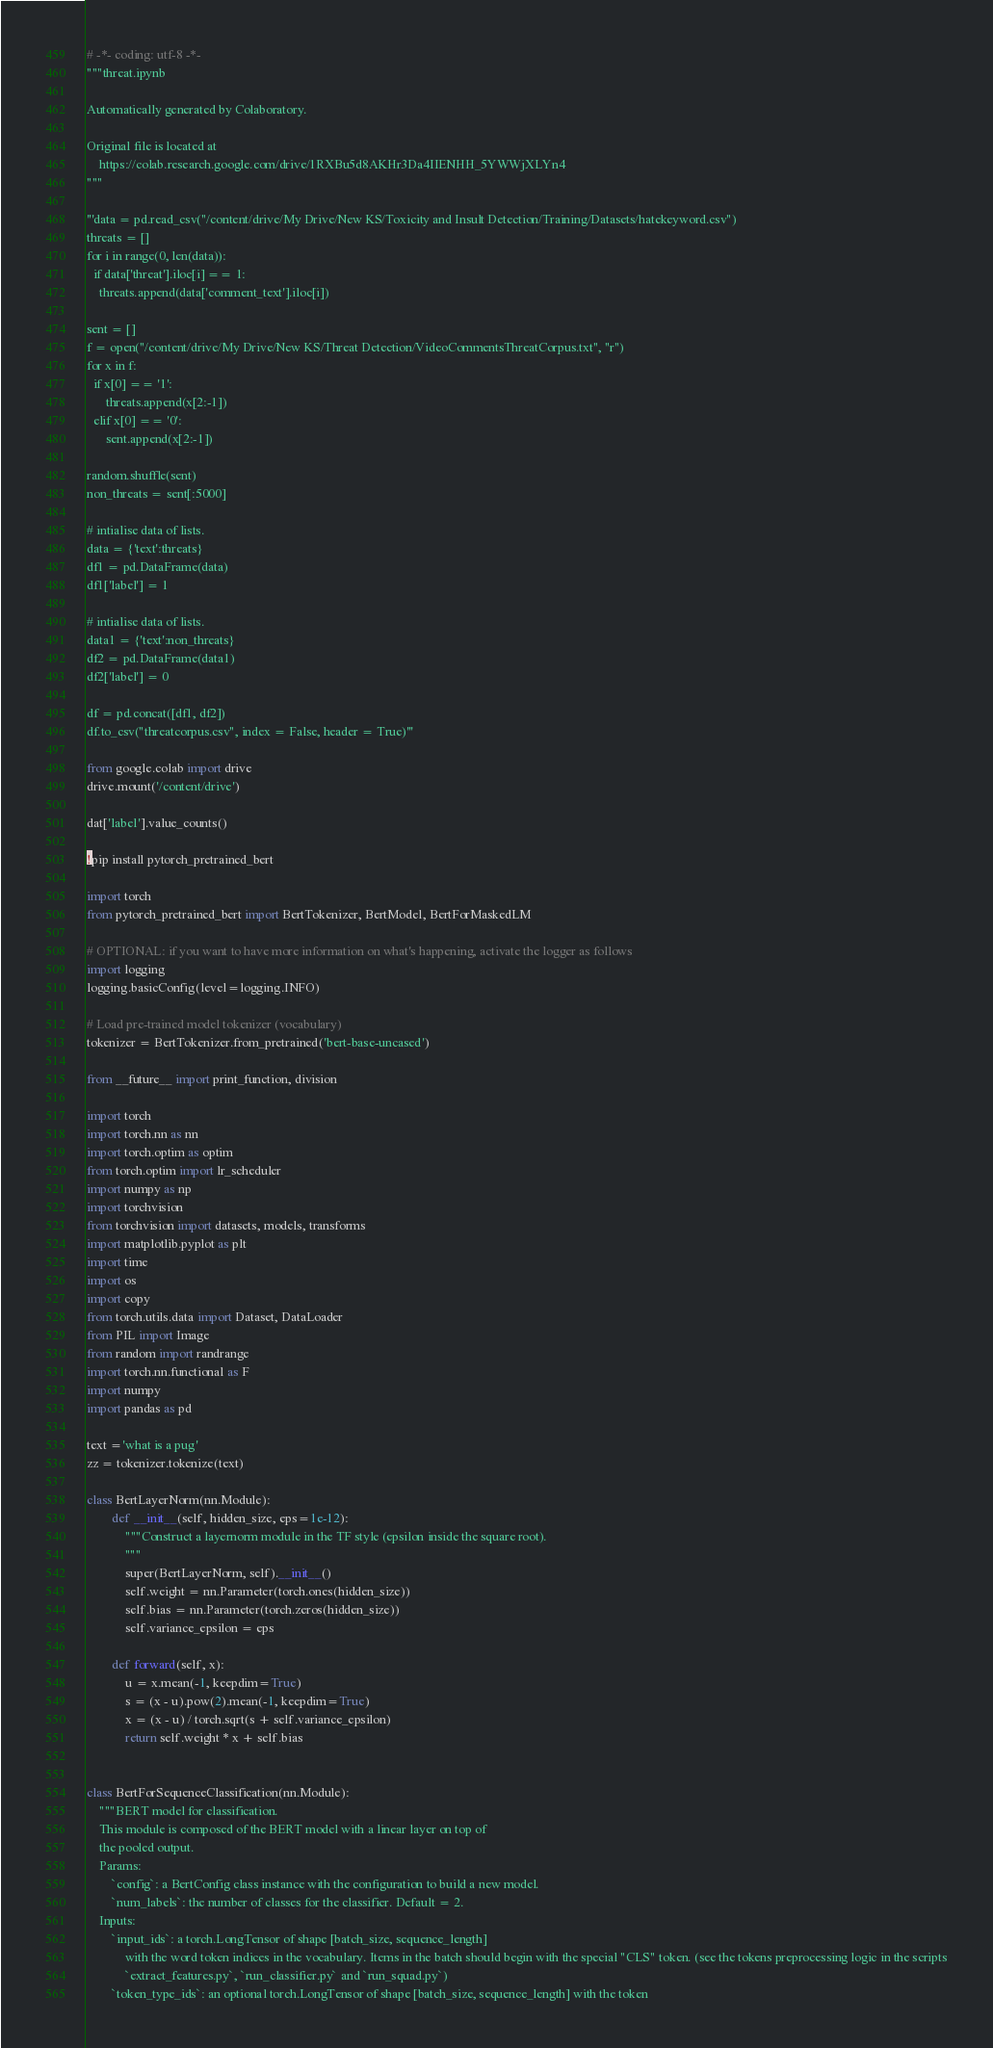Convert code to text. <code><loc_0><loc_0><loc_500><loc_500><_Python_># -*- coding: utf-8 -*-
"""threat.ipynb

Automatically generated by Colaboratory.

Original file is located at
    https://colab.research.google.com/drive/1RXBu5d8AKHr3Da4IIENHH_5YWWjXLYn4
"""

'''data = pd.read_csv("/content/drive/My Drive/New KS/Toxicity and Insult Detection/Training/Datasets/hatekeyword.csv")
threats = []
for i in range(0, len(data)):
  if data['threat'].iloc[i] == 1:
    threats.append(data['comment_text'].iloc[i])

sent = []
f = open("/content/drive/My Drive/New KS/Threat Detection/VideoCommentsThreatCorpus.txt", "r")
for x in f:
  if x[0] == '1':
      threats.append(x[2:-1])
  elif x[0] == '0':
      sent.append(x[2:-1])

random.shuffle(sent)
non_threats = sent[:5000]

# intialise data of lists. 
data = {'text':threats}
df1 = pd.DataFrame(data)
df1['label'] = 1

# intialise data of lists. 
data1 = {'text':non_threats}
df2 = pd.DataFrame(data1)
df2['label'] = 0

df = pd.concat([df1, df2])
df.to_csv("threatcorpus.csv", index = False, header = True)'''

from google.colab import drive
drive.mount('/content/drive')

dat['label'].value_counts()

!pip install pytorch_pretrained_bert

import torch
from pytorch_pretrained_bert import BertTokenizer, BertModel, BertForMaskedLM

# OPTIONAL: if you want to have more information on what's happening, activate the logger as follows
import logging
logging.basicConfig(level=logging.INFO)

# Load pre-trained model tokenizer (vocabulary)
tokenizer = BertTokenizer.from_pretrained('bert-base-uncased')

from __future__ import print_function, division

import torch
import torch.nn as nn
import torch.optim as optim
from torch.optim import lr_scheduler
import numpy as np
import torchvision
from torchvision import datasets, models, transforms
import matplotlib.pyplot as plt
import time
import os
import copy
from torch.utils.data import Dataset, DataLoader
from PIL import Image
from random import randrange
import torch.nn.functional as F
import numpy
import pandas as pd

text ='what is a pug'
zz = tokenizer.tokenize(text)

class BertLayerNorm(nn.Module):
        def __init__(self, hidden_size, eps=1e-12):
            """Construct a layernorm module in the TF style (epsilon inside the square root).
            """
            super(BertLayerNorm, self).__init__()
            self.weight = nn.Parameter(torch.ones(hidden_size))
            self.bias = nn.Parameter(torch.zeros(hidden_size))
            self.variance_epsilon = eps

        def forward(self, x):
            u = x.mean(-1, keepdim=True)
            s = (x - u).pow(2).mean(-1, keepdim=True)
            x = (x - u) / torch.sqrt(s + self.variance_epsilon)
            return self.weight * x + self.bias
        

class BertForSequenceClassification(nn.Module):
    """BERT model for classification.
    This module is composed of the BERT model with a linear layer on top of
    the pooled output.
    Params:
        `config`: a BertConfig class instance with the configuration to build a new model.
        `num_labels`: the number of classes for the classifier. Default = 2.
    Inputs:
        `input_ids`: a torch.LongTensor of shape [batch_size, sequence_length]
            with the word token indices in the vocabulary. Items in the batch should begin with the special "CLS" token. (see the tokens preprocessing logic in the scripts
            `extract_features.py`, `run_classifier.py` and `run_squad.py`)
        `token_type_ids`: an optional torch.LongTensor of shape [batch_size, sequence_length] with the token</code> 